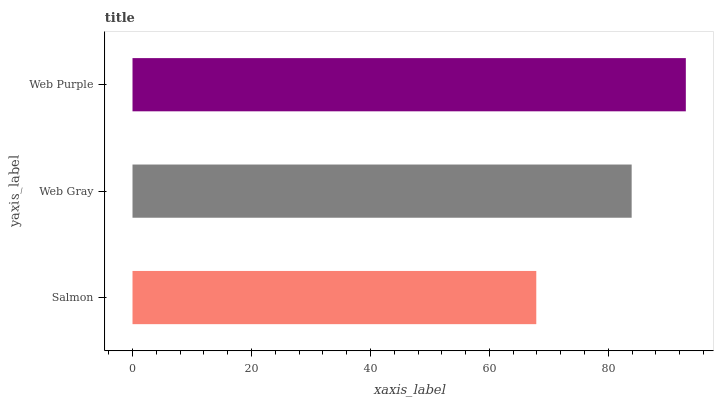Is Salmon the minimum?
Answer yes or no. Yes. Is Web Purple the maximum?
Answer yes or no. Yes. Is Web Gray the minimum?
Answer yes or no. No. Is Web Gray the maximum?
Answer yes or no. No. Is Web Gray greater than Salmon?
Answer yes or no. Yes. Is Salmon less than Web Gray?
Answer yes or no. Yes. Is Salmon greater than Web Gray?
Answer yes or no. No. Is Web Gray less than Salmon?
Answer yes or no. No. Is Web Gray the high median?
Answer yes or no. Yes. Is Web Gray the low median?
Answer yes or no. Yes. Is Salmon the high median?
Answer yes or no. No. Is Web Purple the low median?
Answer yes or no. No. 